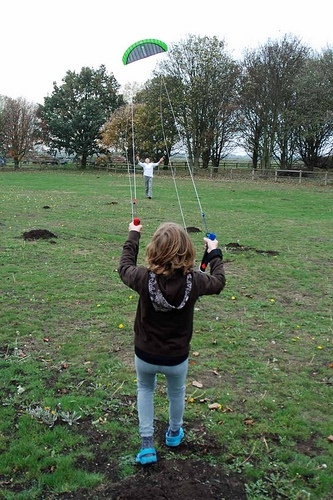Describe the objects in this image and their specific colors. I can see people in white, black, gray, and olive tones, kite in white, gray, and darkgray tones, and people in white, lavender, gray, and darkgray tones in this image. 